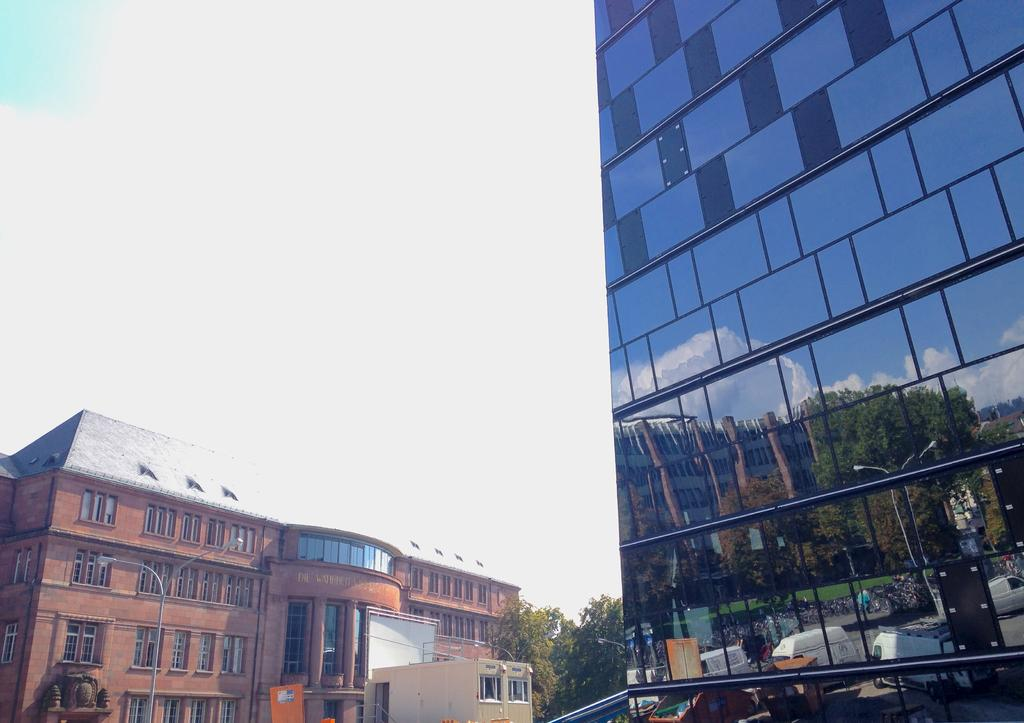What type of building is located in the foreground of the image? There is a glass building in the foreground of the image. On which side of the image is the glass building situated? The glass building is on the right side of the image. What can be seen in the background of the image? There appears to be a vehicle, at least one building, poles, trees, and the sky visible in the background of the image. What type of basketball is being played in the image? There is no basketball or basketball game present in the image. Can you tell me where the camera is located in the image? There is no camera visible in the image. 